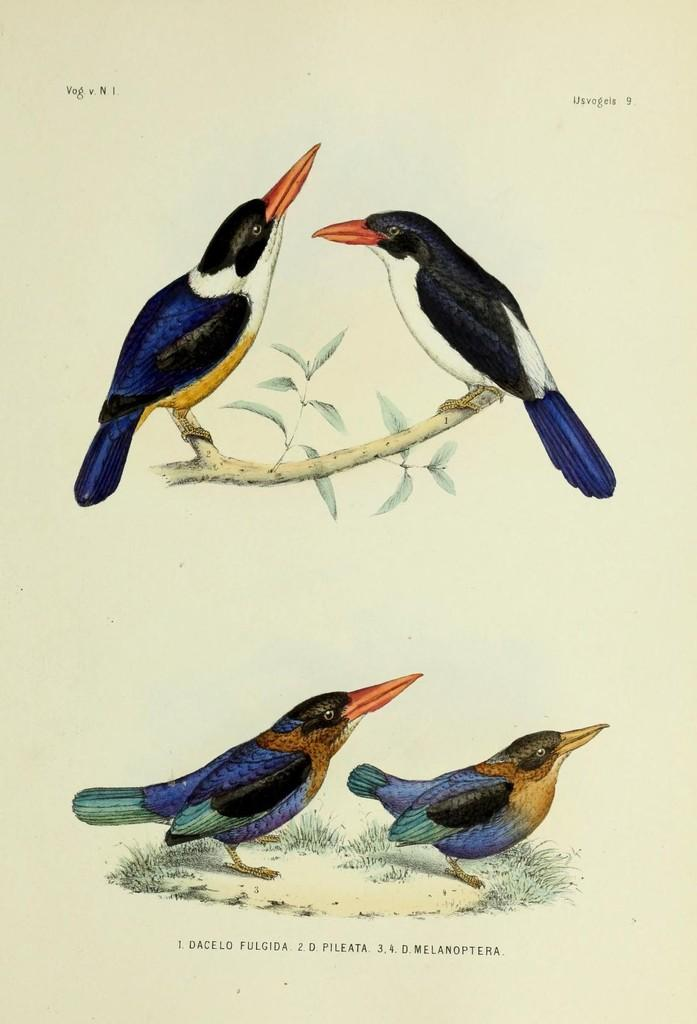What is depicted on the back of the tree in the image? There is a picture of birds on the back of the tree. Are the birds only on the tree, or are they also depicted elsewhere in the image? The birds are also depicted on the land. What can be found at the bottom of the image? There is text written at the bottom of the image. What type of offer is the friend making in the image? There is no friend or offer present in the image; it features a picture of birds on a tree and on the land, along with text at the bottom. 